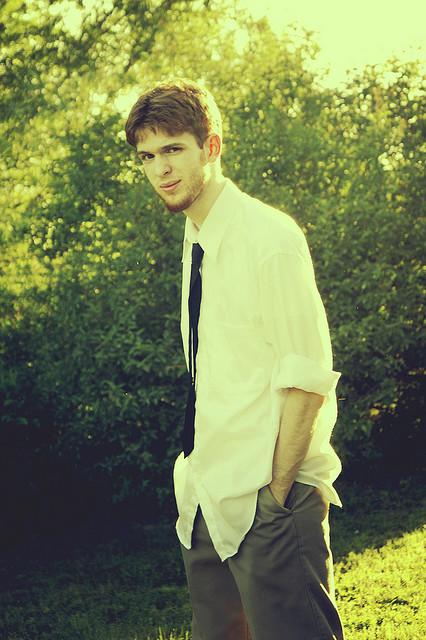Does the man have a beard?
Give a very brief answer. Yes. Is the man wearing a tie?
Quick response, please. Yes. Is the person wearing his shirt tucked in?
Answer briefly. No. 